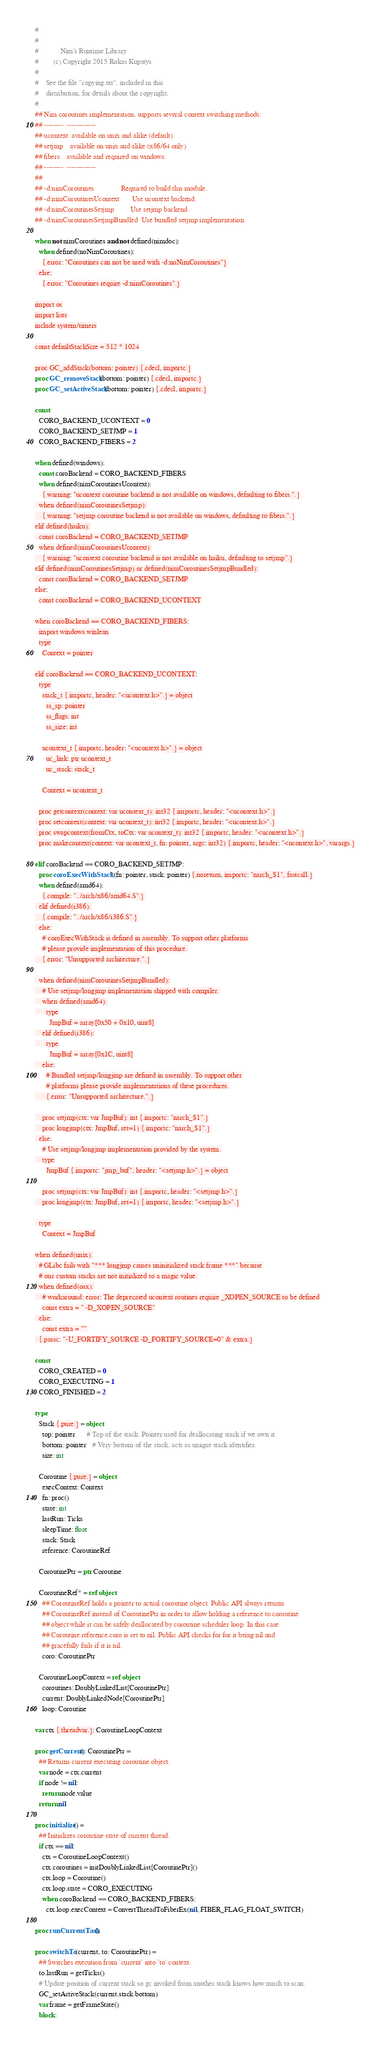Convert code to text. <code><loc_0><loc_0><loc_500><loc_500><_Nim_>#
#
#            Nim's Runtime Library
#        (c) Copyright 2015 Rokas Kupstys
#
#    See the file "copying.txt", included in this
#    distribution, for details about the copyright.
#
## Nim coroutines implementation, supports several context switching methods:
## --------  ------------
## ucontext  available on unix and alike (default)
## setjmp    available on unix and alike (x86/64 only)
## fibers    available and required on windows.
## --------  ------------
##
## -d:nimCoroutines               Required to build this module.
## -d:nimCoroutinesUcontext       Use ucontext backend.
## -d:nimCoroutinesSetjmp         Use setjmp backend.
## -d:nimCoroutinesSetjmpBundled  Use bundled setjmp implementation.

when not nimCoroutines and not defined(nimdoc):
  when defined(noNimCoroutines):
    {.error: "Coroutines can not be used with -d:noNimCoroutines"}
  else:
    {.error: "Coroutines require -d:nimCoroutines".}

import os
import lists
include system/timers

const defaultStackSize = 512 * 1024

proc GC_addStack(bottom: pointer) {.cdecl, importc.}
proc GC_removeStack(bottom: pointer) {.cdecl, importc.}
proc GC_setActiveStack(bottom: pointer) {.cdecl, importc.}

const
  CORO_BACKEND_UCONTEXT = 0
  CORO_BACKEND_SETJMP = 1
  CORO_BACKEND_FIBERS = 2

when defined(windows):
  const coroBackend = CORO_BACKEND_FIBERS
  when defined(nimCoroutinesUcontext):
    {.warning: "ucontext coroutine backend is not available on windows, defaulting to fibers.".}
  when defined(nimCoroutinesSetjmp):
    {.warning: "setjmp coroutine backend is not available on windows, defaulting to fibers.".}
elif defined(haiku):
  const coroBackend = CORO_BACKEND_SETJMP
  when defined(nimCoroutinesUcontext):
    {.warning: "ucontext coroutine backend is not available on haiku, defaulting to setjmp".}
elif defined(nimCoroutinesSetjmp) or defined(nimCoroutinesSetjmpBundled):
  const coroBackend = CORO_BACKEND_SETJMP
else:
  const coroBackend = CORO_BACKEND_UCONTEXT

when coroBackend == CORO_BACKEND_FIBERS:
  import windows.winlean
  type
    Context = pointer

elif coroBackend == CORO_BACKEND_UCONTEXT:
  type
    stack_t {.importc, header: "<ucontext.h>".} = object
      ss_sp: pointer
      ss_flags: int
      ss_size: int

    ucontext_t {.importc, header: "<ucontext.h>".} = object
      uc_link: ptr ucontext_t
      uc_stack: stack_t

    Context = ucontext_t

  proc getcontext(context: var ucontext_t): int32 {.importc, header: "<ucontext.h>".}
  proc setcontext(context: var ucontext_t): int32 {.importc, header: "<ucontext.h>".}
  proc swapcontext(fromCtx, toCtx: var ucontext_t): int32 {.importc, header: "<ucontext.h>".}
  proc makecontext(context: var ucontext_t, fn: pointer, argc: int32) {.importc, header: "<ucontext.h>", varargs.}

elif coroBackend == CORO_BACKEND_SETJMP:
  proc coroExecWithStack*(fn: pointer, stack: pointer) {.noreturn, importc: "narch_$1", fastcall.}
  when defined(amd64):
    {.compile: "../arch/x86/amd64.S".}
  elif defined(i386):
    {.compile: "../arch/x86/i386.S".}
  else:
    # coroExecWithStack is defined in assembly. To support other platforms
    # please provide implementation of this procedure.
    {.error: "Unsupported architecture.".}

  when defined(nimCoroutinesSetjmpBundled):
    # Use setjmp/longjmp implementation shipped with compiler.
    when defined(amd64):
      type
        JmpBuf = array[0x50 + 0x10, uint8]
    elif defined(i386):
      type
        JmpBuf = array[0x1C, uint8]
    else:
      # Bundled setjmp/longjmp are defined in assembly. To support other
      # platforms please provide implementations of these procedures.
      {.error: "Unsupported architecture.".}

    proc setjmp(ctx: var JmpBuf): int {.importc: "narch_$1".}
    proc longjmp(ctx: JmpBuf, ret=1) {.importc: "narch_$1".}
  else:
    # Use setjmp/longjmp implementation provided by the system.
    type
      JmpBuf {.importc: "jmp_buf", header: "<setjmp.h>".} = object

    proc setjmp(ctx: var JmpBuf): int {.importc, header: "<setjmp.h>".}
    proc longjmp(ctx: JmpBuf, ret=1) {.importc, header: "<setjmp.h>".}

  type
    Context = JmpBuf

when defined(unix):
  # GLibc fails with "*** longjmp causes uninitialized stack frame ***" because
  # our custom stacks are not initialized to a magic value.
  when defined(osx):
    # workaround: error: The deprecated ucontext routines require _XOPEN_SOURCE to be defined
    const extra = " -D_XOPEN_SOURCE"
  else:
    const extra = ""
  {.passc: "-U_FORTIFY_SOURCE -D_FORTIFY_SOURCE=0" & extra.}

const
  CORO_CREATED = 0
  CORO_EXECUTING = 1
  CORO_FINISHED = 2

type
  Stack {.pure.} = object
    top: pointer      # Top of the stack. Pointer used for deallocating stack if we own it.
    bottom: pointer   # Very bottom of the stack, acts as unique stack identifier.
    size: int

  Coroutine {.pure.} = object
    execContext: Context
    fn: proc()
    state: int
    lastRun: Ticks
    sleepTime: float
    stack: Stack
    reference: CoroutineRef

  CoroutinePtr = ptr Coroutine

  CoroutineRef* = ref object
    ## CoroutineRef holds a pointer to actual coroutine object. Public API always returns
    ## CoroutineRef instead of CoroutinePtr in order to allow holding a reference to coroutine
    ## object while it can be safely deallocated by coroutine scheduler loop. In this case
    ## Coroutine.reference.coro is set to nil. Public API checks for for it being nil and
    ## gracefully fails if it is nil.
    coro: CoroutinePtr

  CoroutineLoopContext = ref object
    coroutines: DoublyLinkedList[CoroutinePtr]
    current: DoublyLinkedNode[CoroutinePtr]
    loop: Coroutine

var ctx {.threadvar.}: CoroutineLoopContext

proc getCurrent(): CoroutinePtr =
  ## Returns current executing coroutine object.
  var node = ctx.current
  if node != nil:
    return node.value
  return nil

proc initialize() =
  ## Initializes coroutine state of current thread.
  if ctx == nil:
    ctx = CoroutineLoopContext()
    ctx.coroutines = initDoublyLinkedList[CoroutinePtr]()
    ctx.loop = Coroutine()
    ctx.loop.state = CORO_EXECUTING
    when coroBackend == CORO_BACKEND_FIBERS:
      ctx.loop.execContext = ConvertThreadToFiberEx(nil, FIBER_FLAG_FLOAT_SWITCH)

proc runCurrentTask()

proc switchTo(current, to: CoroutinePtr) =
  ## Switches execution from `current` into `to` context.
  to.lastRun = getTicks()
  # Update position of current stack so gc invoked from another stack knows how much to scan.
  GC_setActiveStack(current.stack.bottom)
  var frame = getFrameState()
  block:</code> 